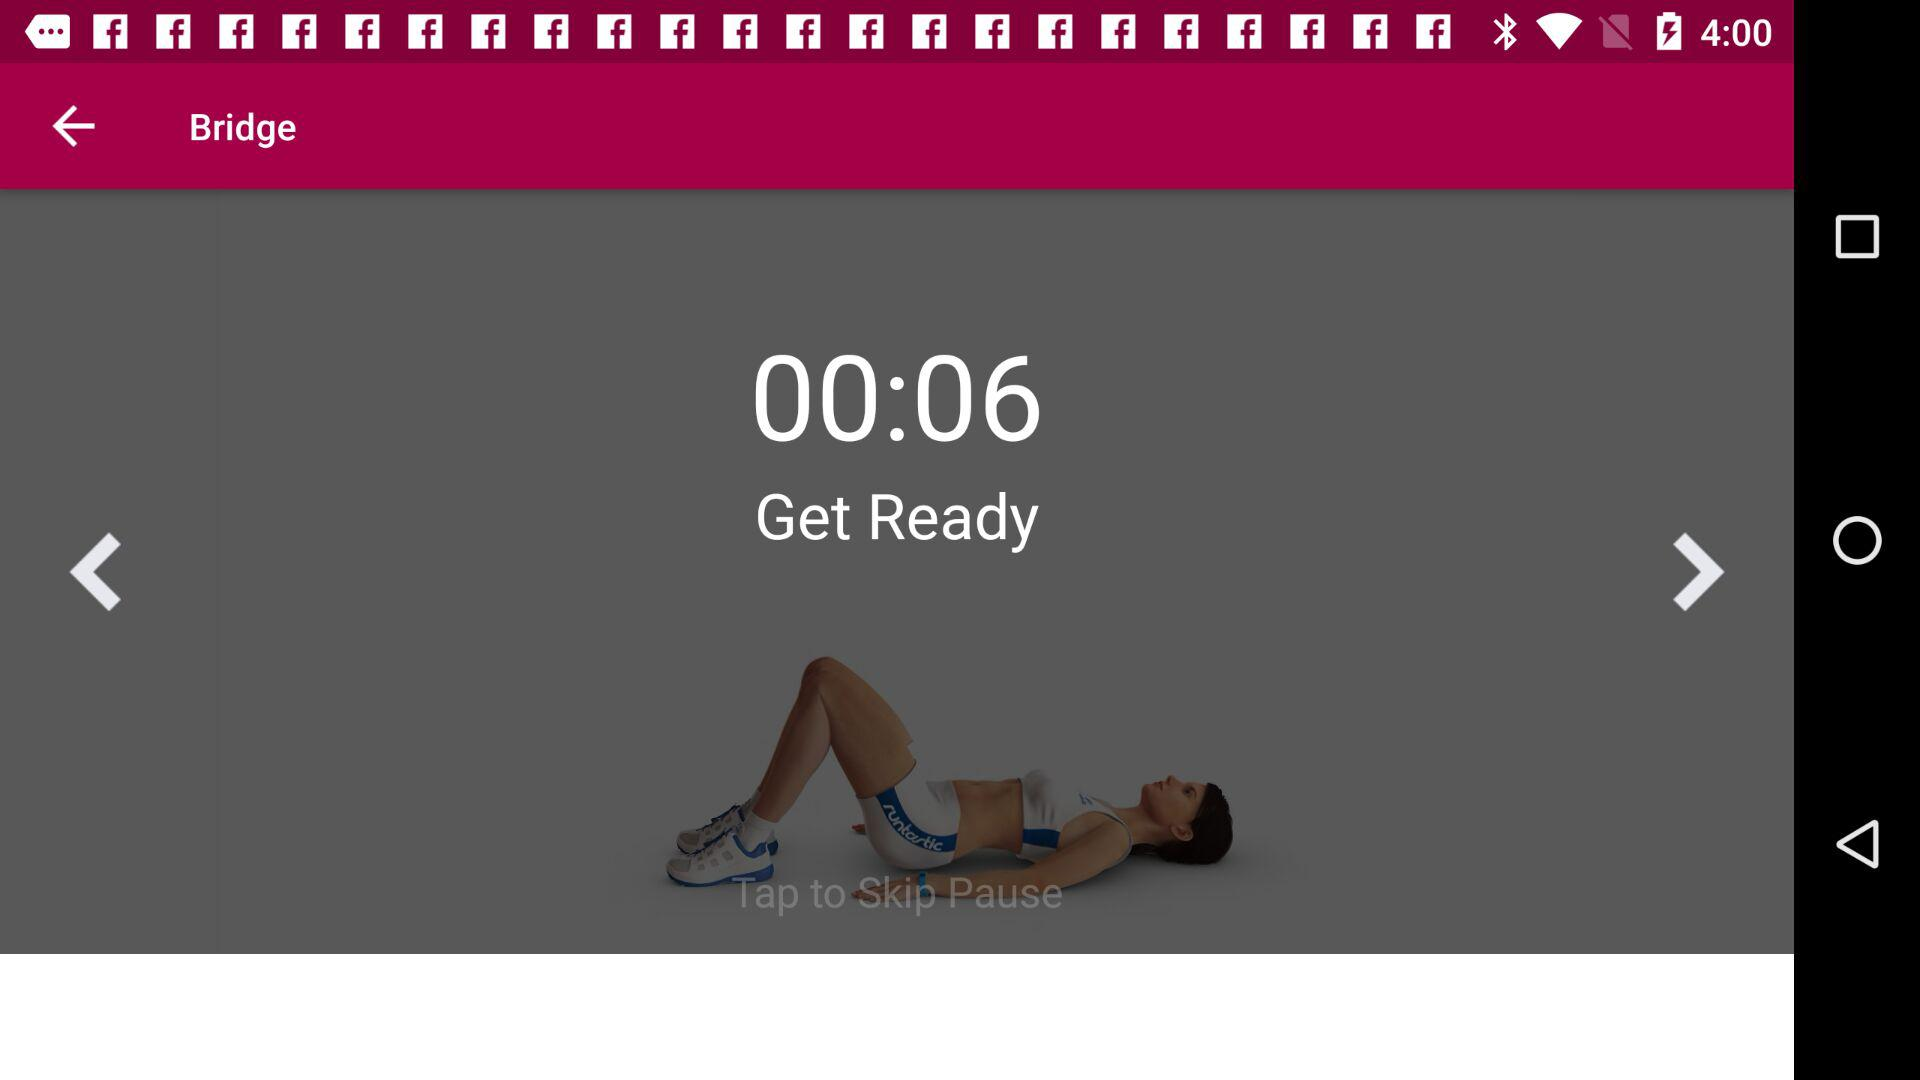How many levels are there?
Answer the question using a single word or phrase. 2 